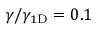<formula> <loc_0><loc_0><loc_500><loc_500>\gamma / \gamma _ { 1 { D } } = 0 . 1</formula> 